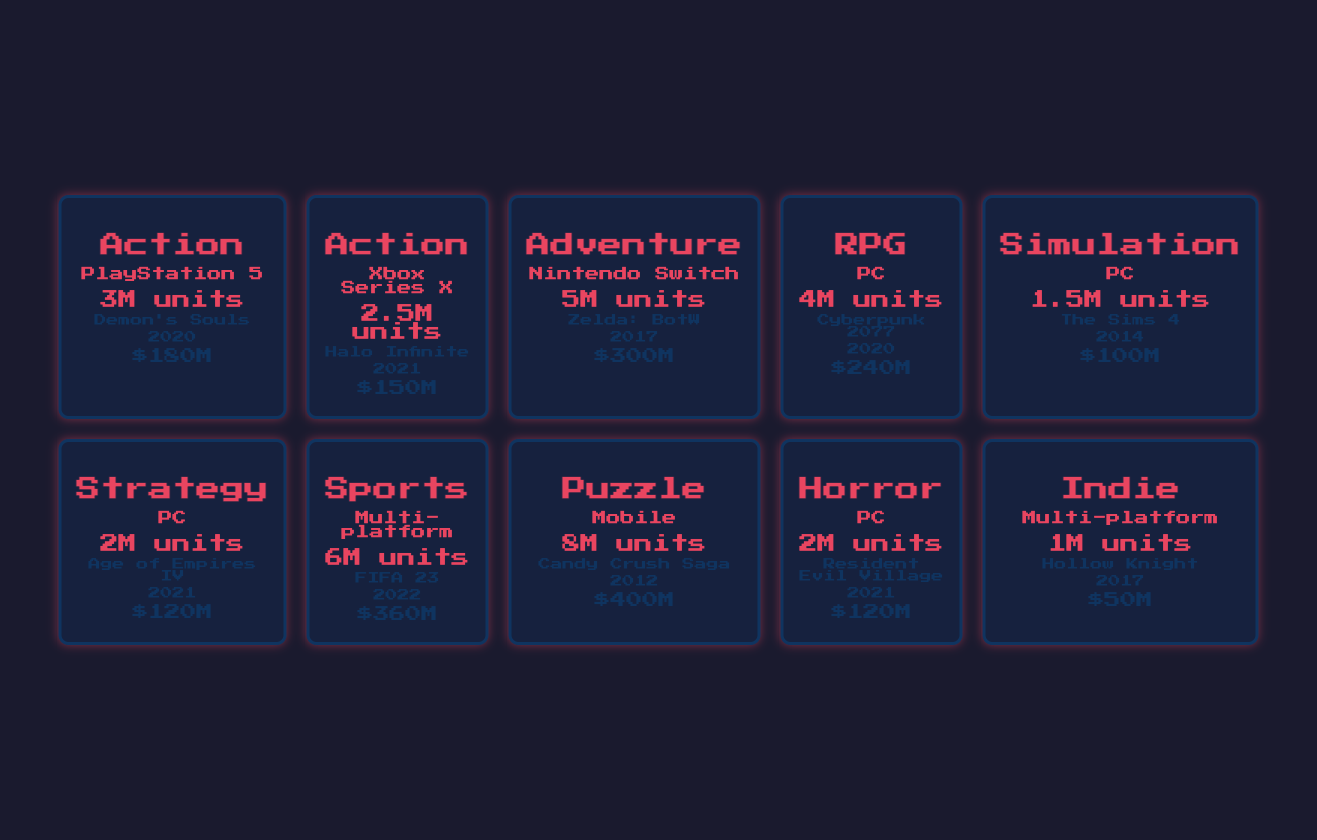What is the top-selling game in the Puzzle genre? The table lists the game "Candy Crush Saga" under the Puzzle genre with sales of 8 million units.
Answer: Candy Crush Saga Which platform has the highest revenue from Action games? The table shows that on PlayStation 5, the Action game "Demon's Souls" generated $180 million, while on Xbox Series X, "Halo Infinite" generated $150 million. Thus, the PlayStation 5 has the highest revenue.
Answer: PlayStation 5 True or False: The top-selling simulation game was released after 2015. "The Sims 4," the top-selling simulation game, was released in 2014, which is before 2015. Thus, the statement is false.
Answer: False What is the total number of units sold for Sports games across all platforms? The table indicates 6 million units sold for "FIFA 23" under Sports; since it's the only sports game listed, the total is 6 million.
Answer: 6 million Which genre has the highest total revenue across all platforms in the table? From the sales data, "Puzzle" from "Candy Crush Saga" has $400 million, "Sports" from "FIFA 23" has $360 million, "Adventure" from "The Legend of Zelda" has $300 million, and so on. The genre with the highest revenue is Puzzle with $400 million.
Answer: Puzzle How many more units were sold for Adventure games compared to Simulation games? Adventure games sold 5 million units ("The Legend of Zelda"), while Simulation sold 1.5 million units ("The Sims 4"). The difference in units sold is 5 million - 1.5 million = 3.5 million.
Answer: 3.5 million True or False: All RPG games listed were released in 2021. There is one RPG listed, "Cyberpunk 2077," which was released in 2020. Therefore, the statement is false.
Answer: False What is the average revenue of all the games listed in the table? The total revenue for all games is $180M + $150M + $300M + $240M + $100M + $120M + $360M + $400M + $120M + $50M = $2,020 million, and there are 10 games. The average revenue is $2,020 million / 10 = $202 million.
Answer: $202 million Which genre and platform combination has the least units sold? The combination with the least units sold is the Indie genre on Multi-platform with 1 million units sold (from "Hollow Knight").
Answer: Indie on Multi-platform 